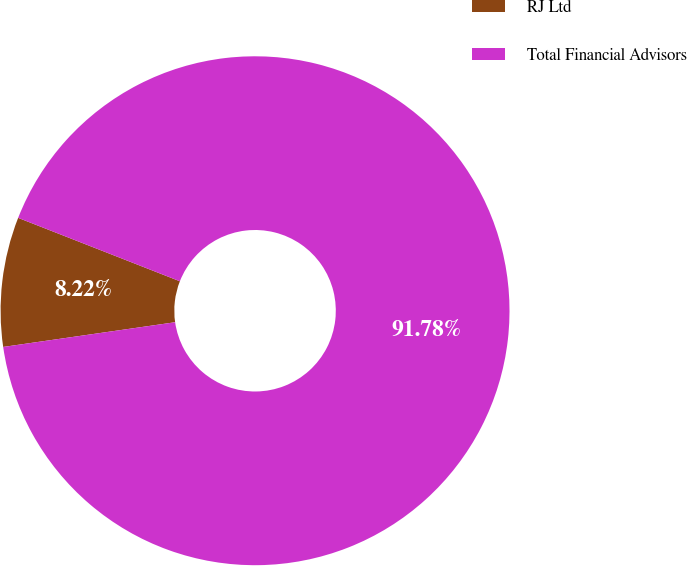<chart> <loc_0><loc_0><loc_500><loc_500><pie_chart><fcel>RJ Ltd<fcel>Total Financial Advisors<nl><fcel>8.22%<fcel>91.78%<nl></chart> 